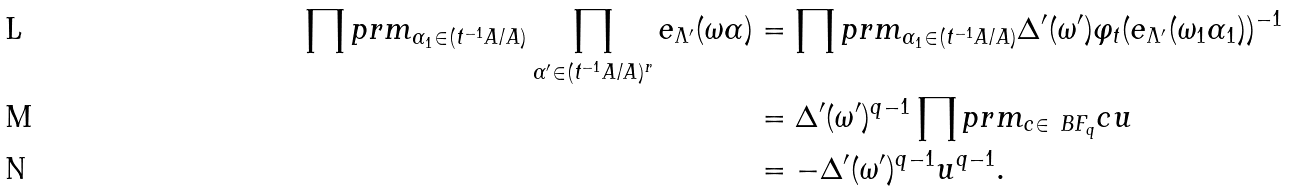<formula> <loc_0><loc_0><loc_500><loc_500>\prod p r m _ { \alpha _ { 1 } \in ( t ^ { - 1 } A / A ) } \prod _ { \alpha ^ { \prime } \in ( t ^ { - 1 } A / A ) ^ { r } } e _ { \Lambda ^ { \prime } } ( \omega \alpha ) & = \prod p r m _ { \alpha _ { 1 } \in ( t ^ { - 1 } A / A ) } \Delta ^ { \prime } ( \omega ^ { \prime } ) \varphi _ { t } ( e _ { \Lambda ^ { \prime } } ( \omega _ { 1 } \alpha _ { 1 } ) ) ^ { - 1 } \\ & = \Delta ^ { \prime } ( \omega ^ { \prime } ) ^ { q - 1 } \prod p r m _ { c \in \ B F _ { q } } c u \\ & = - \Delta ^ { \prime } ( \omega ^ { \prime } ) ^ { q - 1 } u ^ { q - 1 } .</formula> 